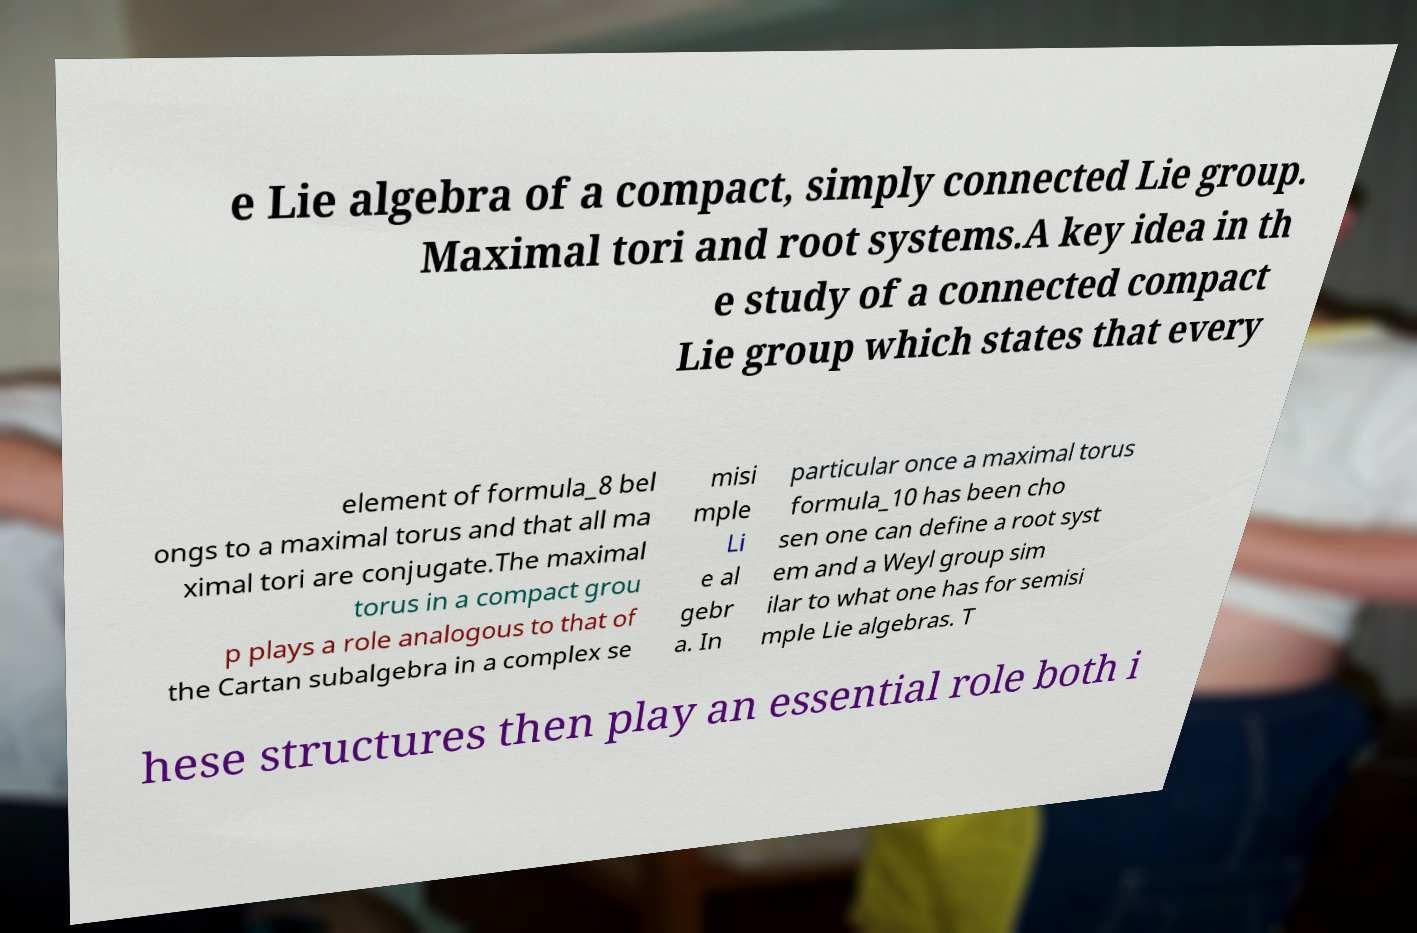Please identify and transcribe the text found in this image. e Lie algebra of a compact, simply connected Lie group. Maximal tori and root systems.A key idea in th e study of a connected compact Lie group which states that every element of formula_8 bel ongs to a maximal torus and that all ma ximal tori are conjugate.The maximal torus in a compact grou p plays a role analogous to that of the Cartan subalgebra in a complex se misi mple Li e al gebr a. In particular once a maximal torus formula_10 has been cho sen one can define a root syst em and a Weyl group sim ilar to what one has for semisi mple Lie algebras. T hese structures then play an essential role both i 